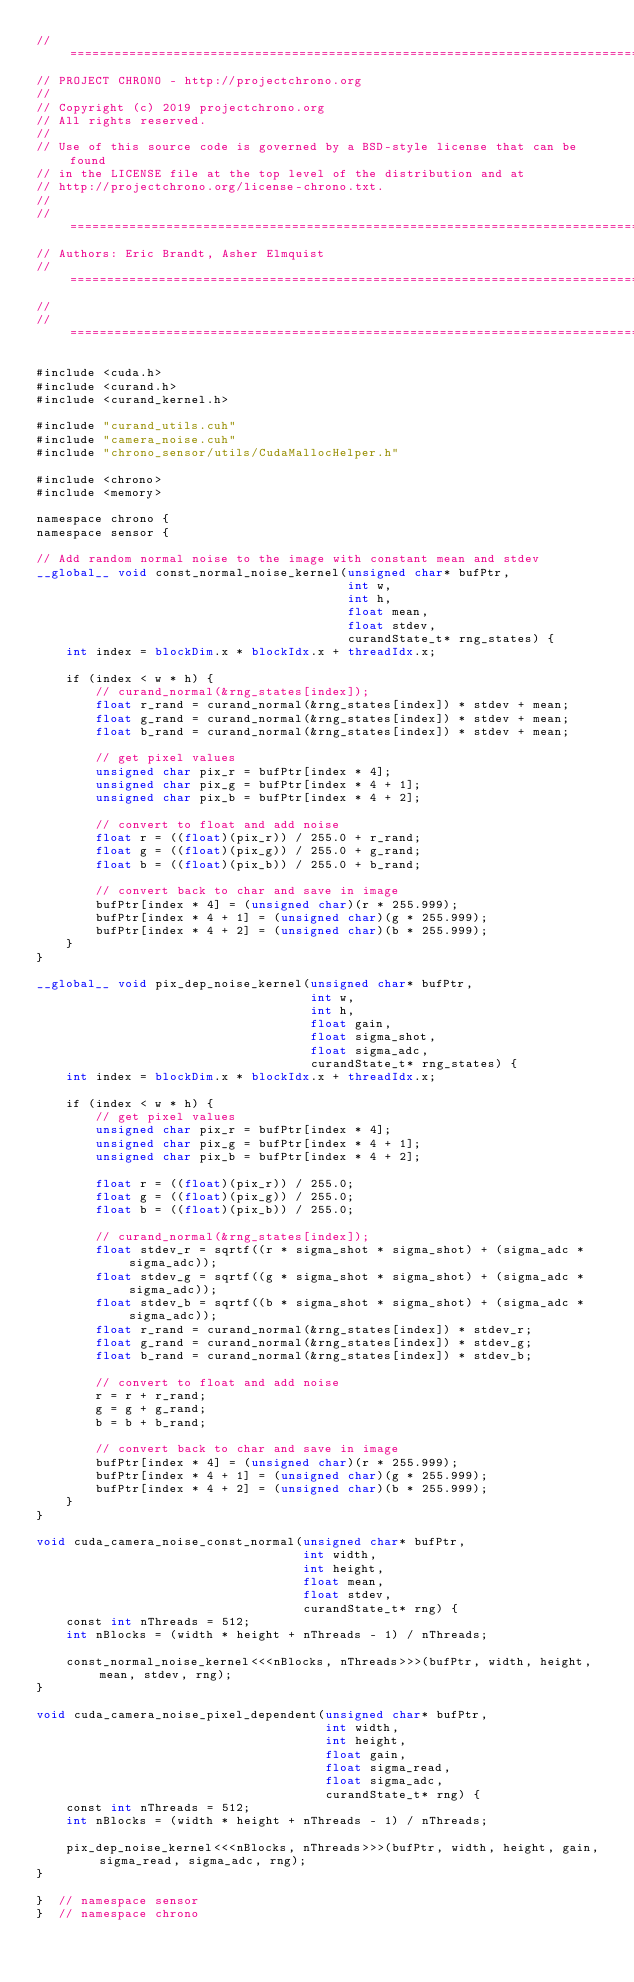Convert code to text. <code><loc_0><loc_0><loc_500><loc_500><_Cuda_>// =============================================================================
// PROJECT CHRONO - http://projectchrono.org
//
// Copyright (c) 2019 projectchrono.org
// All rights reserved.
//
// Use of this source code is governed by a BSD-style license that can be found
// in the LICENSE file at the top level of the distribution and at
// http://projectchrono.org/license-chrono.txt.
//
// =============================================================================
// Authors: Eric Brandt, Asher Elmquist
// =============================================================================
//
// =============================================================================

#include <cuda.h>
#include <curand.h>
#include <curand_kernel.h>

#include "curand_utils.cuh"
#include "camera_noise.cuh"
#include "chrono_sensor/utils/CudaMallocHelper.h"

#include <chrono>
#include <memory>

namespace chrono {
namespace sensor {

// Add random normal noise to the image with constant mean and stdev
__global__ void const_normal_noise_kernel(unsigned char* bufPtr,
                                          int w,
                                          int h,
                                          float mean,
                                          float stdev,
                                          curandState_t* rng_states) {
    int index = blockDim.x * blockIdx.x + threadIdx.x;

    if (index < w * h) {
        // curand_normal(&rng_states[index]);
        float r_rand = curand_normal(&rng_states[index]) * stdev + mean;
        float g_rand = curand_normal(&rng_states[index]) * stdev + mean;
        float b_rand = curand_normal(&rng_states[index]) * stdev + mean;

        // get pixel values
        unsigned char pix_r = bufPtr[index * 4];
        unsigned char pix_g = bufPtr[index * 4 + 1];
        unsigned char pix_b = bufPtr[index * 4 + 2];

        // convert to float and add noise
        float r = ((float)(pix_r)) / 255.0 + r_rand;
        float g = ((float)(pix_g)) / 255.0 + g_rand;
        float b = ((float)(pix_b)) / 255.0 + b_rand;

        // convert back to char and save in image
        bufPtr[index * 4] = (unsigned char)(r * 255.999);
        bufPtr[index * 4 + 1] = (unsigned char)(g * 255.999);
        bufPtr[index * 4 + 2] = (unsigned char)(b * 255.999);
    }
}

__global__ void pix_dep_noise_kernel(unsigned char* bufPtr,
                                     int w,
                                     int h,
                                     float gain,
                                     float sigma_shot,
                                     float sigma_adc,
                                     curandState_t* rng_states) {
    int index = blockDim.x * blockIdx.x + threadIdx.x;

    if (index < w * h) {
        // get pixel values
        unsigned char pix_r = bufPtr[index * 4];
        unsigned char pix_g = bufPtr[index * 4 + 1];
        unsigned char pix_b = bufPtr[index * 4 + 2];

        float r = ((float)(pix_r)) / 255.0;
        float g = ((float)(pix_g)) / 255.0;
        float b = ((float)(pix_b)) / 255.0;

        // curand_normal(&rng_states[index]);
        float stdev_r = sqrtf((r * sigma_shot * sigma_shot) + (sigma_adc * sigma_adc));
        float stdev_g = sqrtf((g * sigma_shot * sigma_shot) + (sigma_adc * sigma_adc));
        float stdev_b = sqrtf((b * sigma_shot * sigma_shot) + (sigma_adc * sigma_adc));
        float r_rand = curand_normal(&rng_states[index]) * stdev_r;
        float g_rand = curand_normal(&rng_states[index]) * stdev_g;
        float b_rand = curand_normal(&rng_states[index]) * stdev_b;

        // convert to float and add noise
        r = r + r_rand;
        g = g + g_rand;
        b = b + b_rand;

        // convert back to char and save in image
        bufPtr[index * 4] = (unsigned char)(r * 255.999);
        bufPtr[index * 4 + 1] = (unsigned char)(g * 255.999);
        bufPtr[index * 4 + 2] = (unsigned char)(b * 255.999);
    }
}

void cuda_camera_noise_const_normal(unsigned char* bufPtr,
                                    int width,
                                    int height,
                                    float mean,
                                    float stdev,
                                    curandState_t* rng) {
    const int nThreads = 512;
    int nBlocks = (width * height + nThreads - 1) / nThreads;

    const_normal_noise_kernel<<<nBlocks, nThreads>>>(bufPtr, width, height, mean, stdev, rng);
}

void cuda_camera_noise_pixel_dependent(unsigned char* bufPtr,
                                       int width,
                                       int height,
                                       float gain,
                                       float sigma_read,
                                       float sigma_adc,
                                       curandState_t* rng) {
    const int nThreads = 512;
    int nBlocks = (width * height + nThreads - 1) / nThreads;

    pix_dep_noise_kernel<<<nBlocks, nThreads>>>(bufPtr, width, height, gain, sigma_read, sigma_adc, rng);
}

}  // namespace sensor
}  // namespace chrono
</code> 